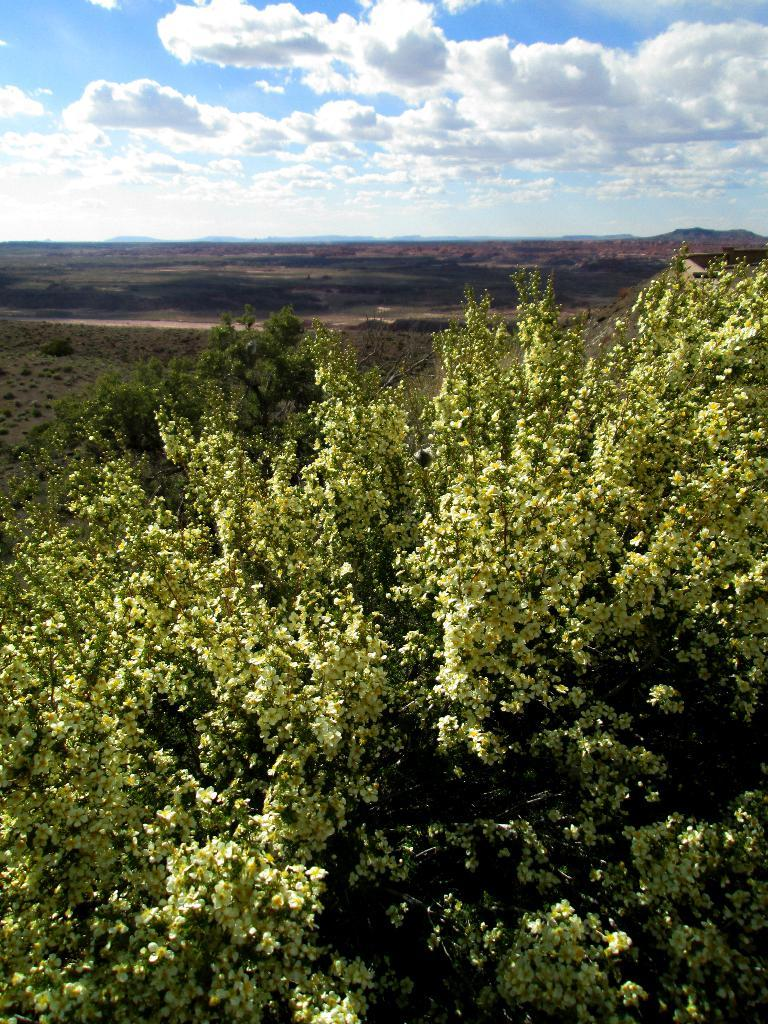What type of vegetation can be seen in the image? There are trees and plants in the image. What part of the natural environment is visible in the image? The sky is visible in the image. What can be seen in the sky? Clouds are present in the sky. What direction are the ants moving in the image? There are no ants present in the image. How does the brake function in the image? There is no brake present in the image. 